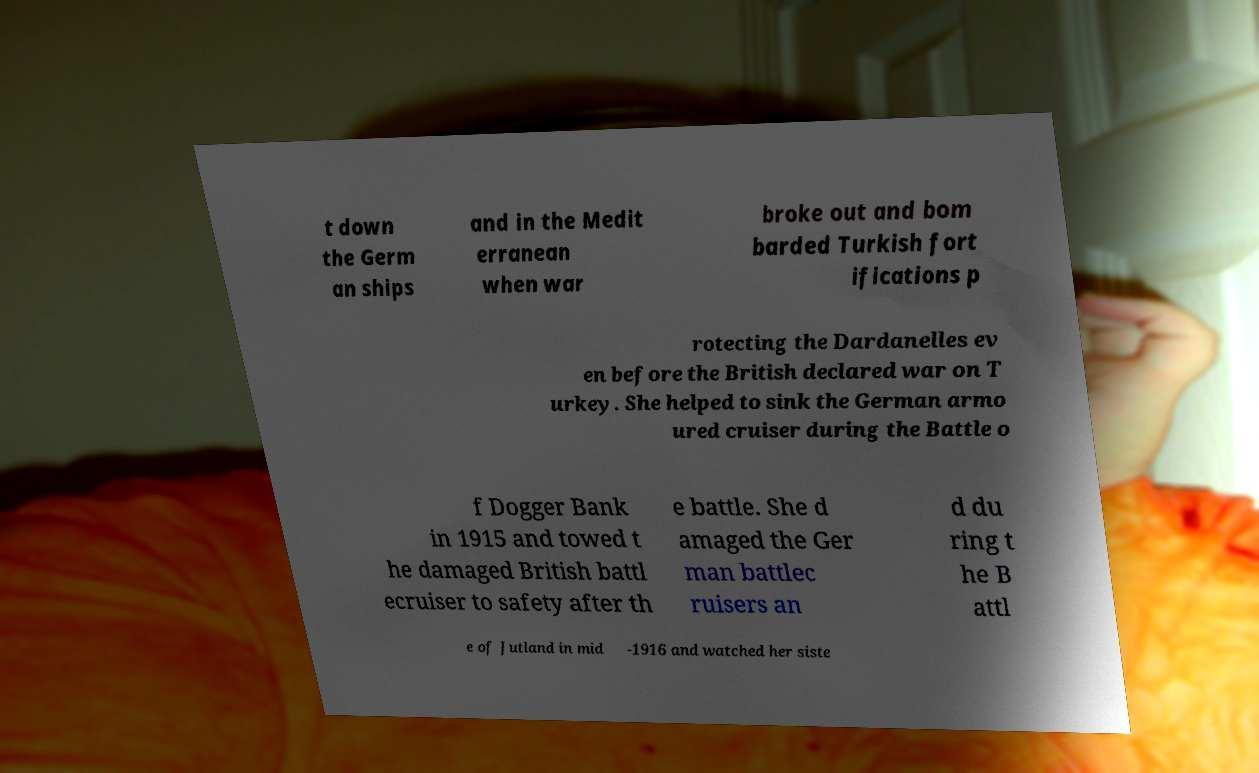For documentation purposes, I need the text within this image transcribed. Could you provide that? t down the Germ an ships and in the Medit erranean when war broke out and bom barded Turkish fort ifications p rotecting the Dardanelles ev en before the British declared war on T urkey. She helped to sink the German armo ured cruiser during the Battle o f Dogger Bank in 1915 and towed t he damaged British battl ecruiser to safety after th e battle. She d amaged the Ger man battlec ruisers an d du ring t he B attl e of Jutland in mid -1916 and watched her siste 